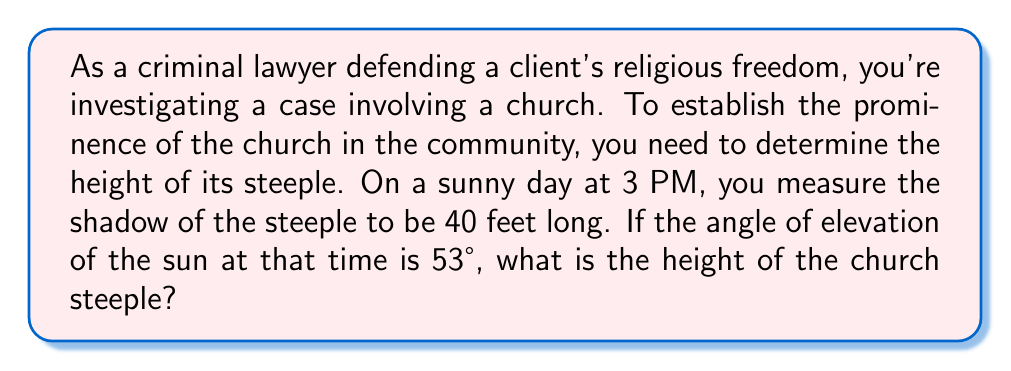Can you solve this math problem? Let's approach this step-by-step using trigonometry:

1) First, let's visualize the problem:

[asy]
import geometry;

pair A = (0,0), B = (40,0), C = (0,30);
draw(A--B--C--A);
draw(rightanglemark(A,B,C,8));

label("40 ft",B,S);
label("h",C,W);
label("53°",A,NE);

dot("A",A,SW);
dot("B",B,SE);
dot("C",C,NW);
[/asy]

2) We have a right triangle where:
   - The shadow length is the base (adjacent to the angle)
   - The steeple height is the opposite side
   - The angle of elevation of the sun is the angle we're given

3) We can use the tangent function, which is defined as:

   $$\tan \theta = \frac{\text{opposite}}{\text{adjacent}}$$

4) In our case:

   $$\tan 53° = \frac{\text{height}}{\text{shadow length}}$$

5) Let's substitute the known values:

   $$\tan 53° = \frac{h}{40}$$

6) To solve for $h$, multiply both sides by 40:

   $$40 \tan 53° = h$$

7) Now, we can calculate:
   $$h = 40 \cdot \tan 53° \approx 40 \cdot 1.3270 \approx 53.08 \text{ feet}$$

8) Rounding to the nearest foot, the steeple height is 53 feet.
Answer: 53 feet 